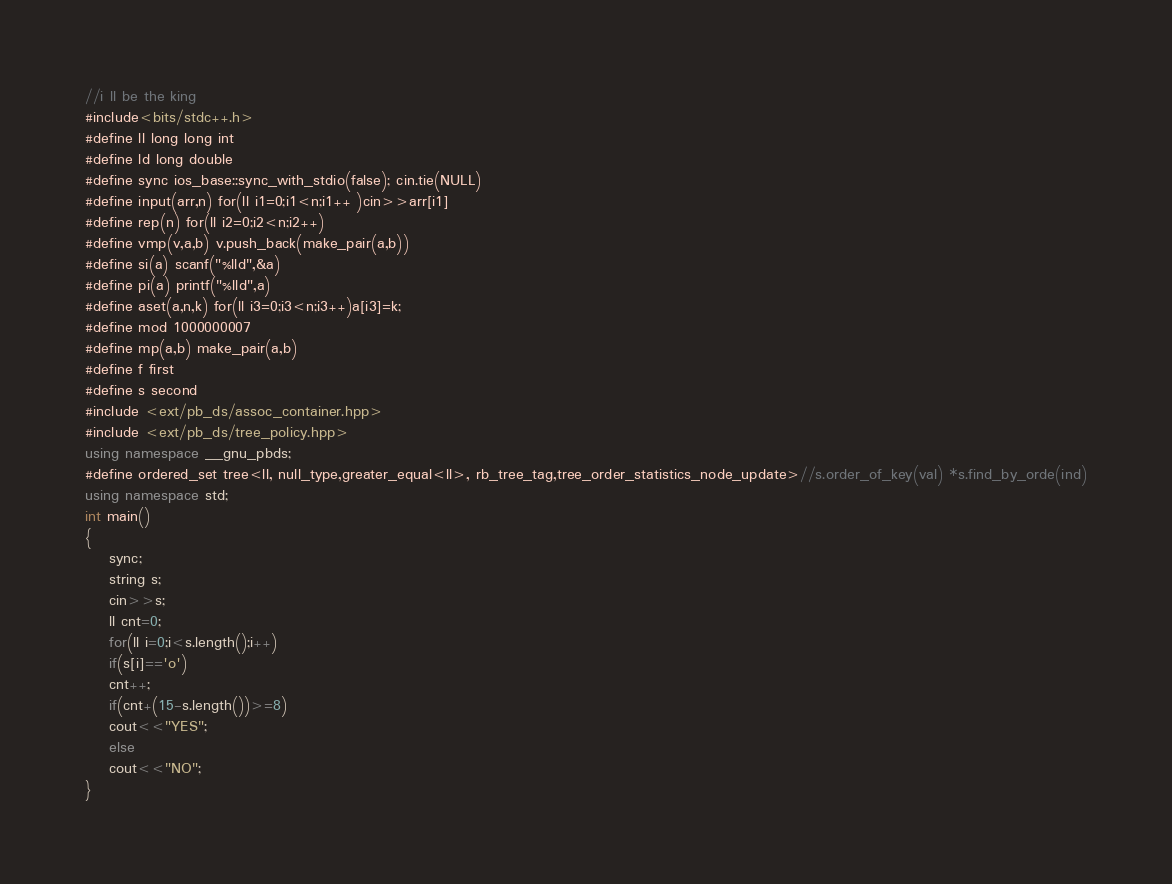Convert code to text. <code><loc_0><loc_0><loc_500><loc_500><_C++_>//i ll be the king
#include<bits/stdc++.h>
#define ll long long int
#define ld long double
#define sync ios_base::sync_with_stdio(false); cin.tie(NULL) 
#define input(arr,n) for(ll i1=0;i1<n;i1++ )cin>>arr[i1]
#define rep(n) for(ll i2=0;i2<n;i2++)
#define vmp(v,a,b) v.push_back(make_pair(a,b))
#define si(a) scanf("%lld",&a)
#define pi(a) printf("%lld",a)
#define aset(a,n,k) for(ll i3=0;i3<n;i3++)a[i3]=k; 	
#define mod 1000000007
#define mp(a,b) make_pair(a,b)
#define f first
#define s second 
#include <ext/pb_ds/assoc_container.hpp>
#include <ext/pb_ds/tree_policy.hpp>
using namespace __gnu_pbds;
#define ordered_set tree<ll, null_type,greater_equal<ll>, rb_tree_tag,tree_order_statistics_node_update>//s.order_of_key(val) *s.find_by_orde(ind)
using namespace std;
int main()
{
	sync;
	string s;
	cin>>s;
	ll cnt=0;
	for(ll i=0;i<s.length();i++)
	if(s[i]=='o')
	cnt++;
	if(cnt+(15-s.length())>=8)
	cout<<"YES";
	else
	cout<<"NO";
}</code> 